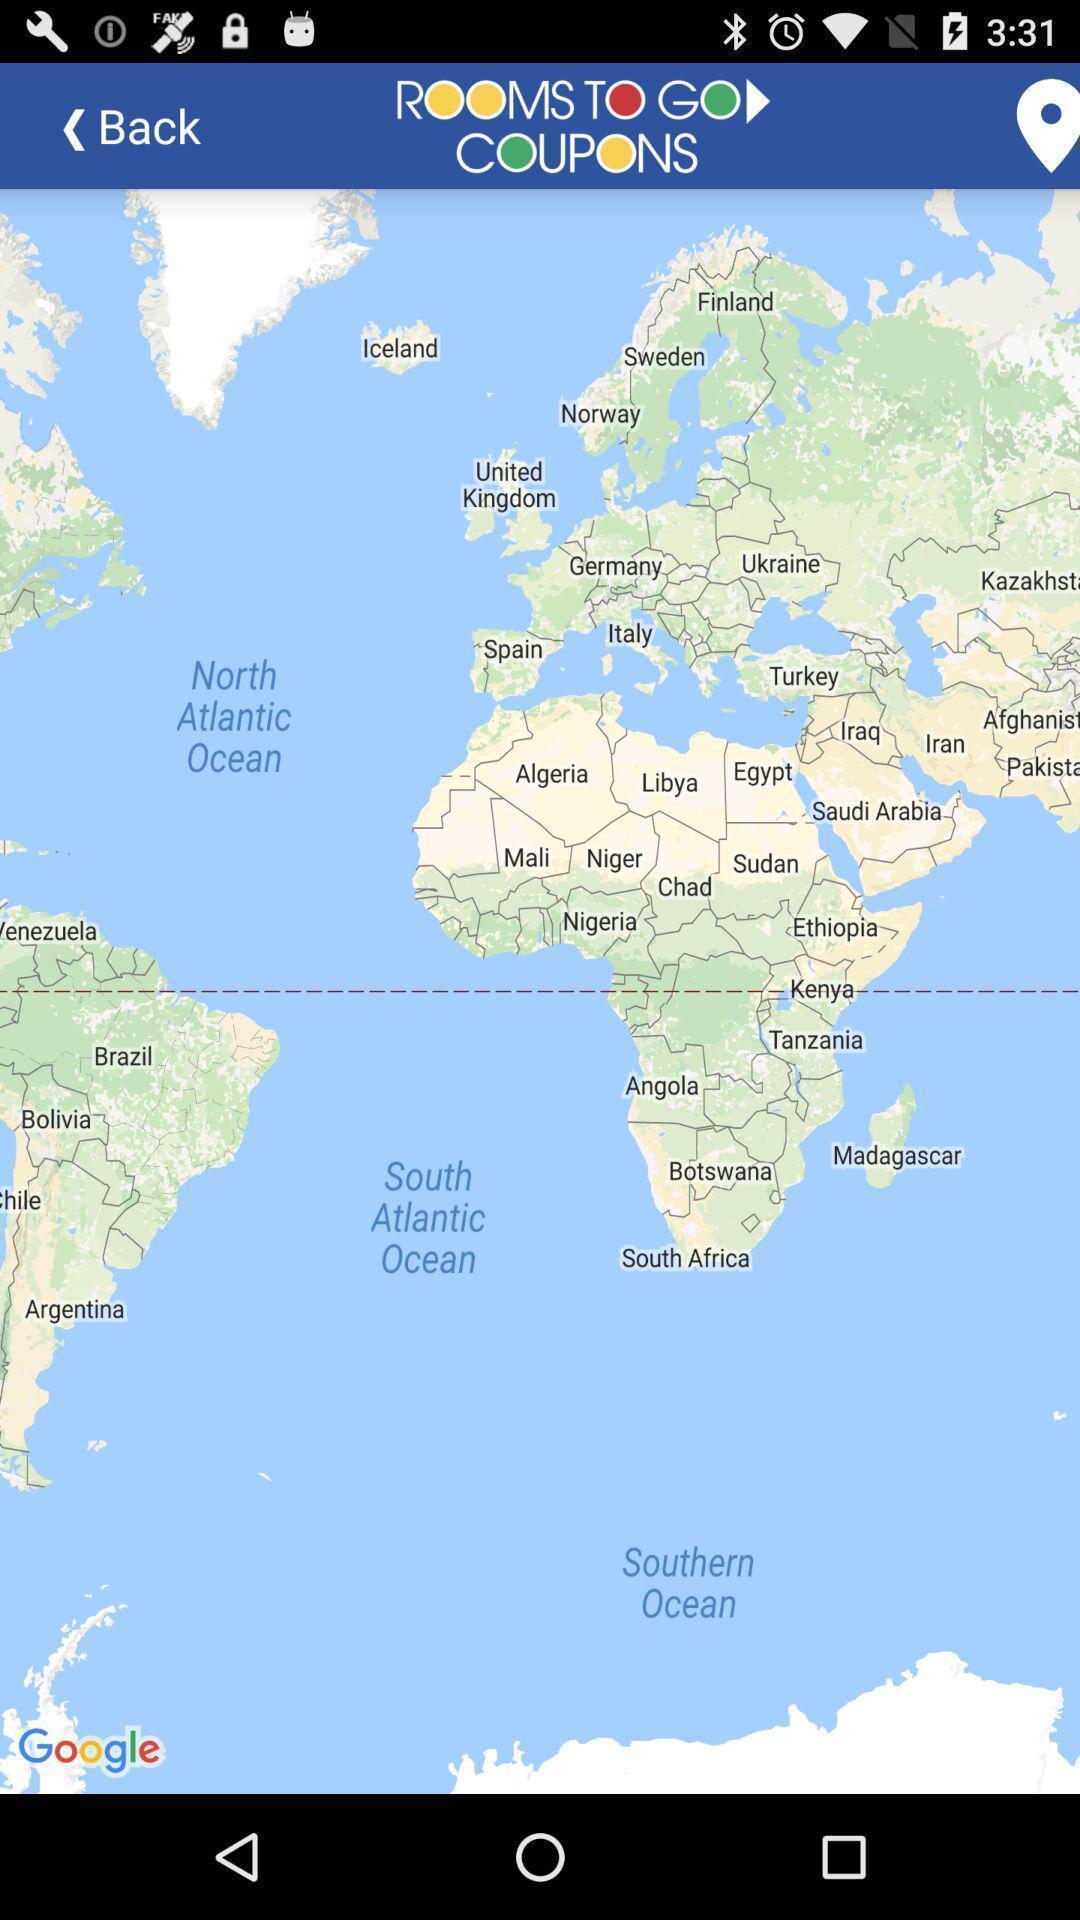Describe the content in this image. Page showing map of a location. 